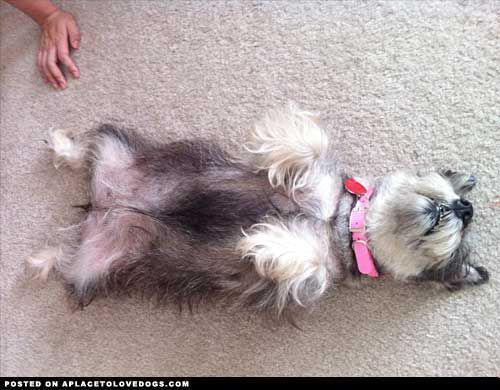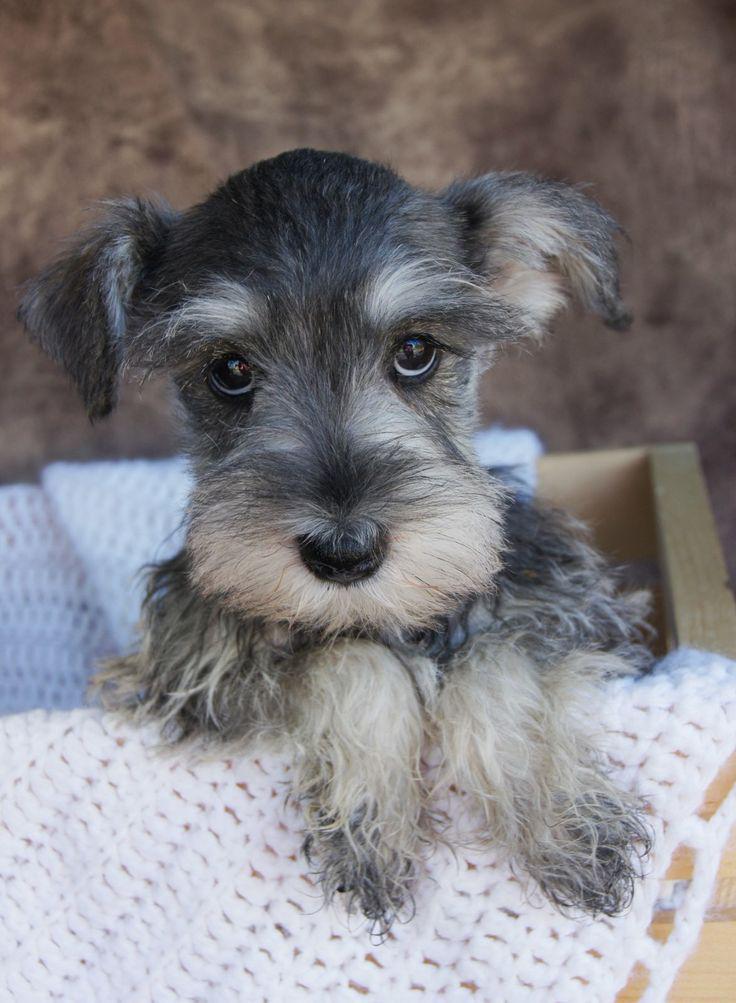The first image is the image on the left, the second image is the image on the right. For the images shown, is this caption "Each image contains one schnauzer posed on a piece of soft furniture." true? Answer yes or no. No. The first image is the image on the left, the second image is the image on the right. Assess this claim about the two images: "A dog is lying down on a white bed sheet in the left image.". Correct or not? Answer yes or no. No. 